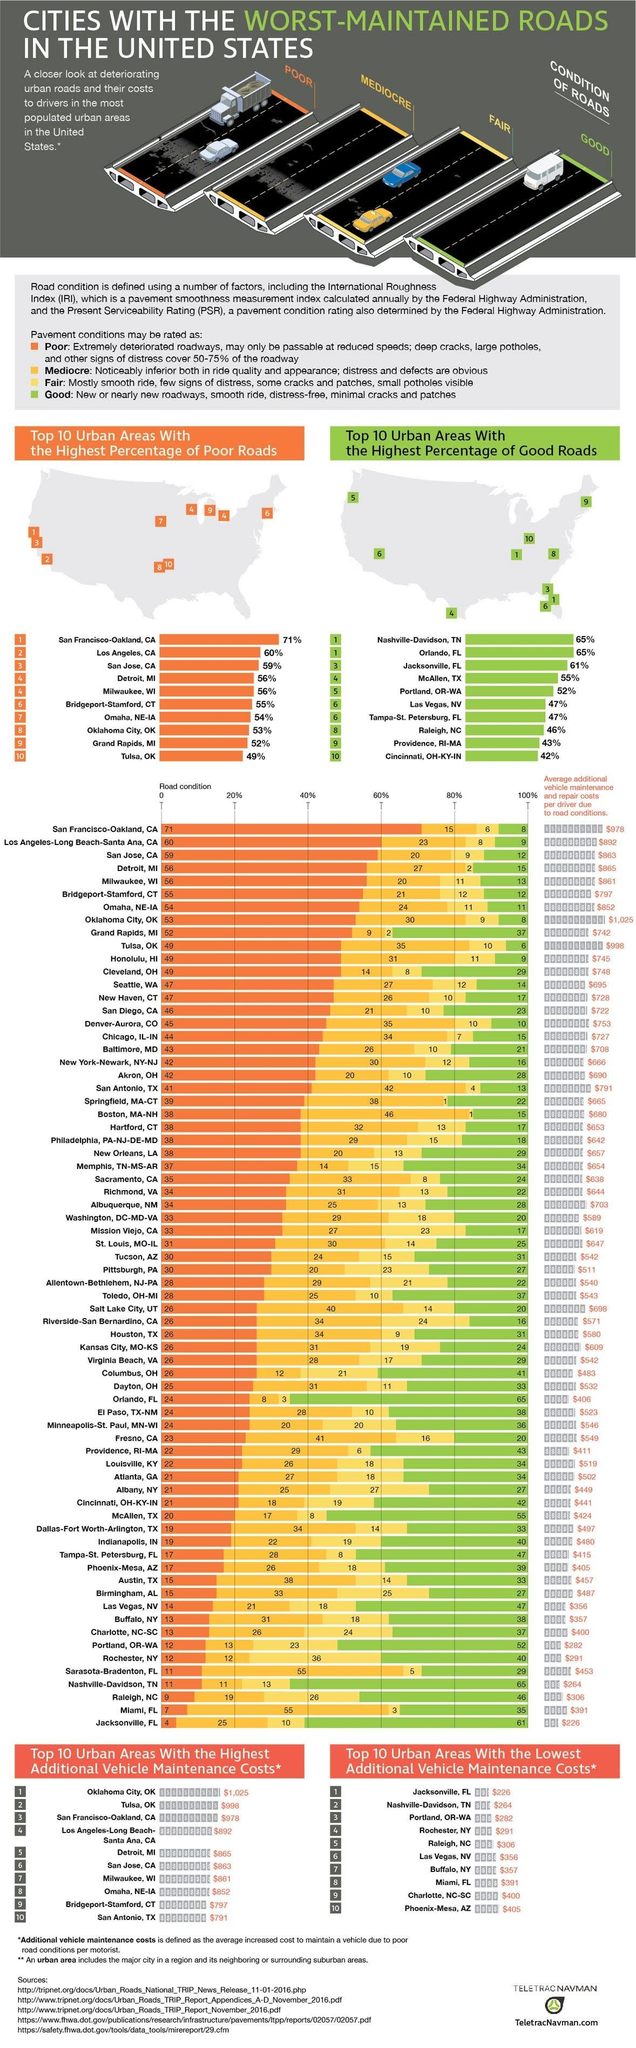Highlight a few significant elements in this photo. According to recent data, 55% of the roads in McAllen, TX are in good condition. Tulsa, Oklahoma has the second highest additional vehicle maintenance costs in an urban area in the United States. The additional vehicle maintenance cost in urban areas of Rochester, New York is estimated to be approximately $291. In urban areas of Raleigh, NC, approximately 46% of the roads are in good condition. Oklahoma City, Oklahoma is the city with the highest additional vehicle maintenance costs in the United States. 